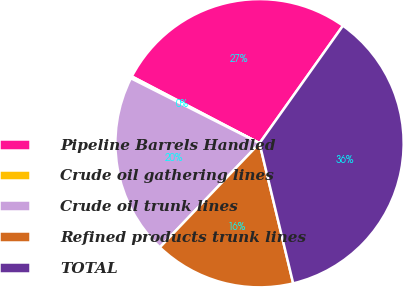<chart> <loc_0><loc_0><loc_500><loc_500><pie_chart><fcel>Pipeline Barrels Handled<fcel>Crude oil gathering lines<fcel>Crude oil trunk lines<fcel>Refined products trunk lines<fcel>TOTAL<nl><fcel>27.15%<fcel>0.23%<fcel>20.29%<fcel>15.9%<fcel>36.42%<nl></chart> 